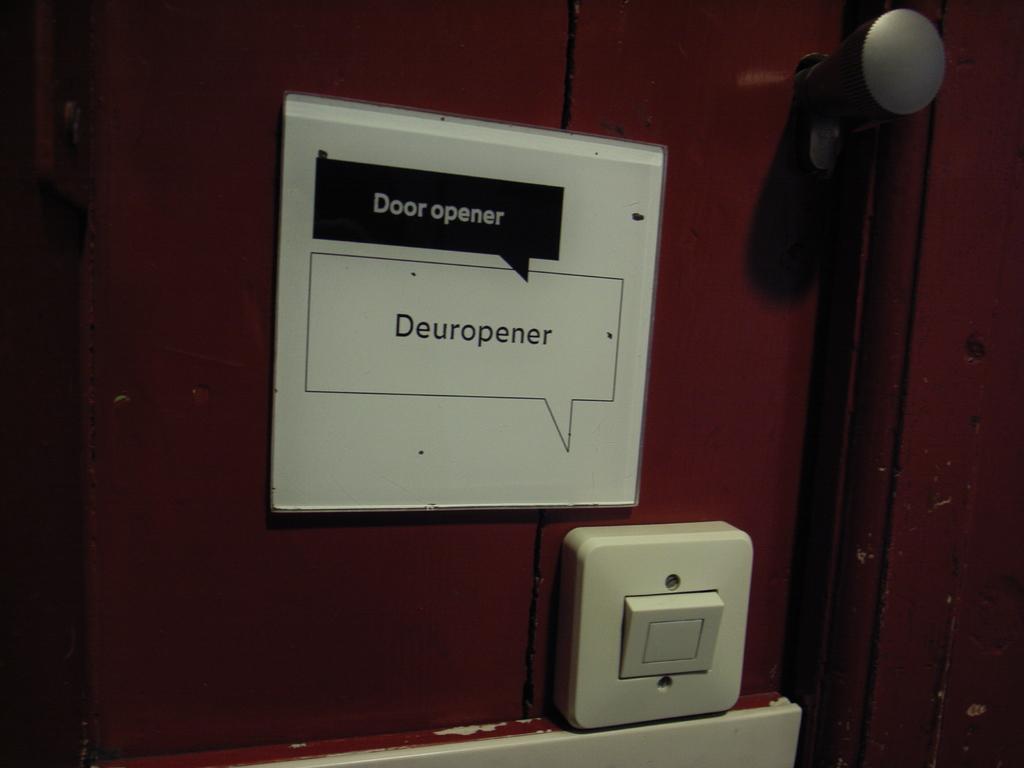What is written in the black text box?
Your response must be concise. Door opener. What is the first word of the text in the blcak box?
Keep it short and to the point. Door. 